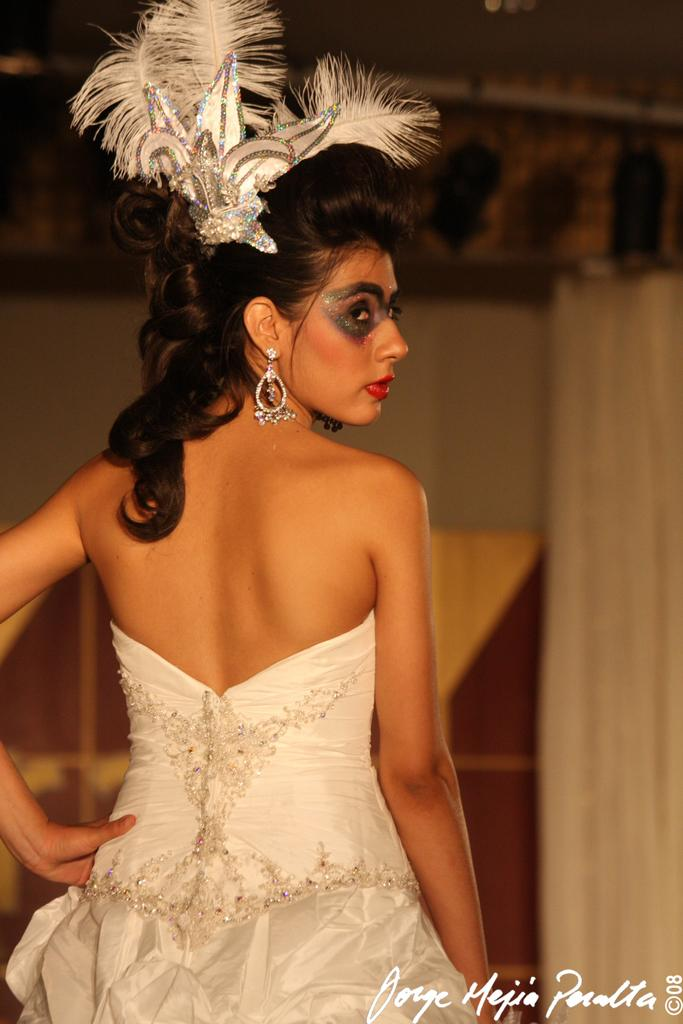Who is the main subject in the image? There is a woman in the image. What is the woman wearing? The woman is wearing a white dress. Are there any accessories or decorations on the woman? Yes, there are white feathers on her head. Is there any text in the image? Yes, there is text in the right-hand side bottom of the image. What type of egg is being used for lunch in the image? There is no egg or lunch depicted in the image; it features a woman wearing a white dress with white feathers on her head and text at the bottom right corner. 